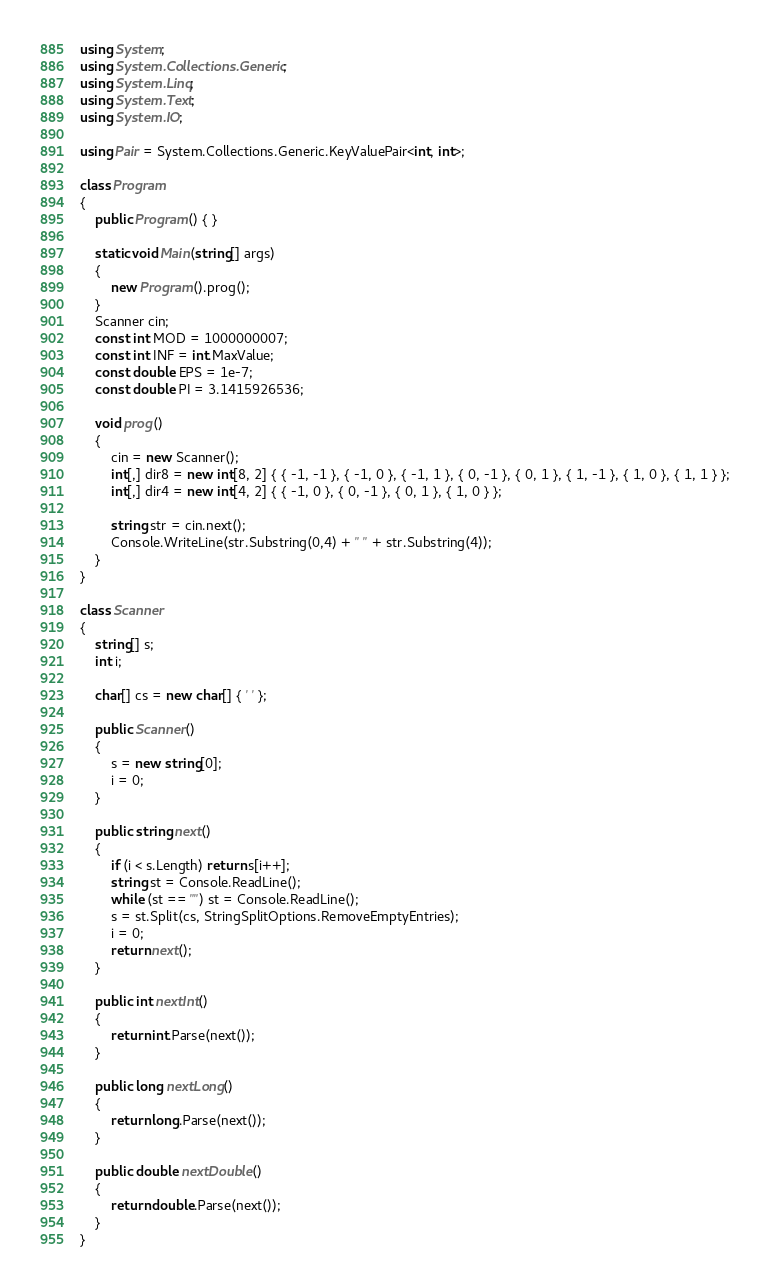<code> <loc_0><loc_0><loc_500><loc_500><_C#_>using System;
using System.Collections.Generic;
using System.Linq;
using System.Text;
using System.IO;

using Pair = System.Collections.Generic.KeyValuePair<int, int>;

class Program
{
	public Program() { }

	static void Main(string[] args)
	{
		new Program().prog();
	}
	Scanner cin;
	const int MOD = 1000000007;
	const int INF = int.MaxValue;
	const double EPS = 1e-7;
	const double PI = 3.1415926536;

	void prog()
	{
		cin = new Scanner();
		int[,] dir8 = new int[8, 2] { { -1, -1 }, { -1, 0 }, { -1, 1 }, { 0, -1 }, { 0, 1 }, { 1, -1 }, { 1, 0 }, { 1, 1 } };
		int[,] dir4 = new int[4, 2] { { -1, 0 }, { 0, -1 }, { 0, 1 }, { 1, 0 } };

		string str = cin.next();
		Console.WriteLine(str.Substring(0,4) + " " + str.Substring(4));
	}
}

class Scanner
{
	string[] s;
	int i;

	char[] cs = new char[] { ' ' };

	public Scanner()
	{
		s = new string[0];
		i = 0;
	}

	public string next()
	{
		if (i < s.Length) return s[i++];
		string st = Console.ReadLine();
		while (st == "") st = Console.ReadLine();
		s = st.Split(cs, StringSplitOptions.RemoveEmptyEntries);
		i = 0;
		return next();
	}

	public int nextInt()
	{
		return int.Parse(next());
	}

	public long nextLong()
	{
		return long.Parse(next());
	}

	public double nextDouble()
	{
		return double.Parse(next());
	}
}</code> 